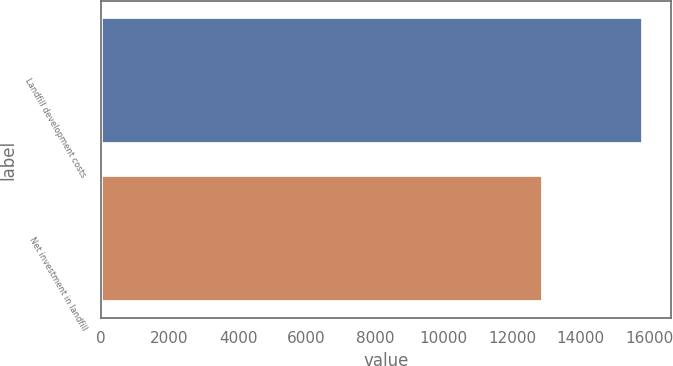Convert chart to OTSL. <chart><loc_0><loc_0><loc_500><loc_500><bar_chart><fcel>Landfill development costs<fcel>Net investment in landfill<nl><fcel>15829.1<fcel>12911.9<nl></chart> 